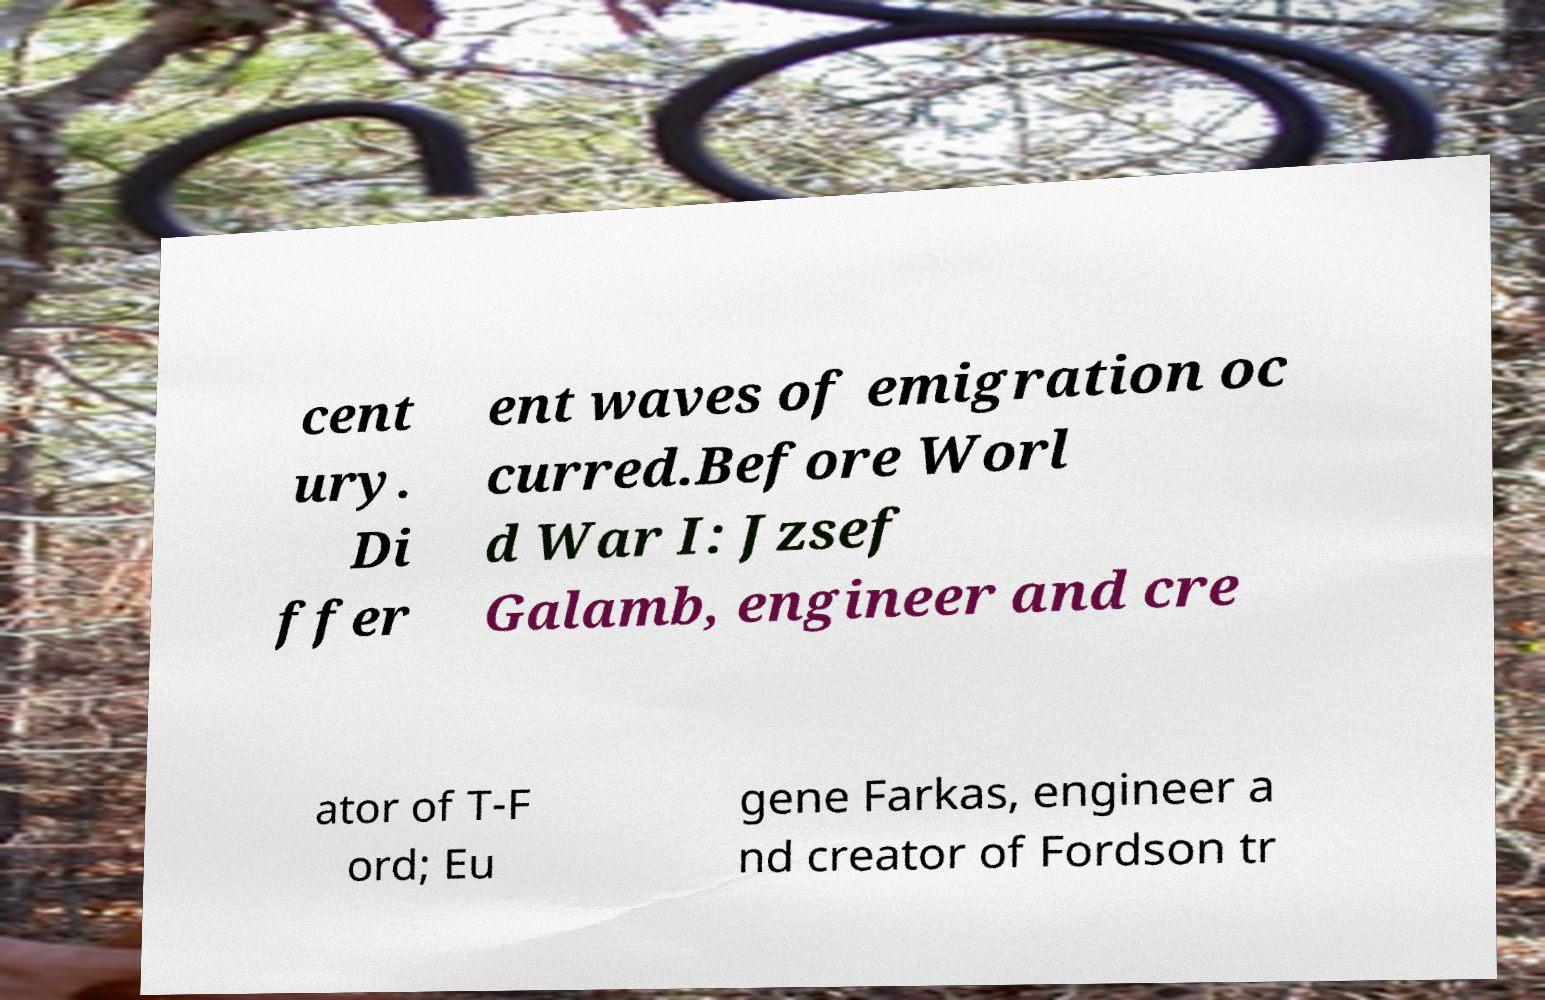For documentation purposes, I need the text within this image transcribed. Could you provide that? cent ury. Di ffer ent waves of emigration oc curred.Before Worl d War I: Jzsef Galamb, engineer and cre ator of T-F ord; Eu gene Farkas, engineer a nd creator of Fordson tr 